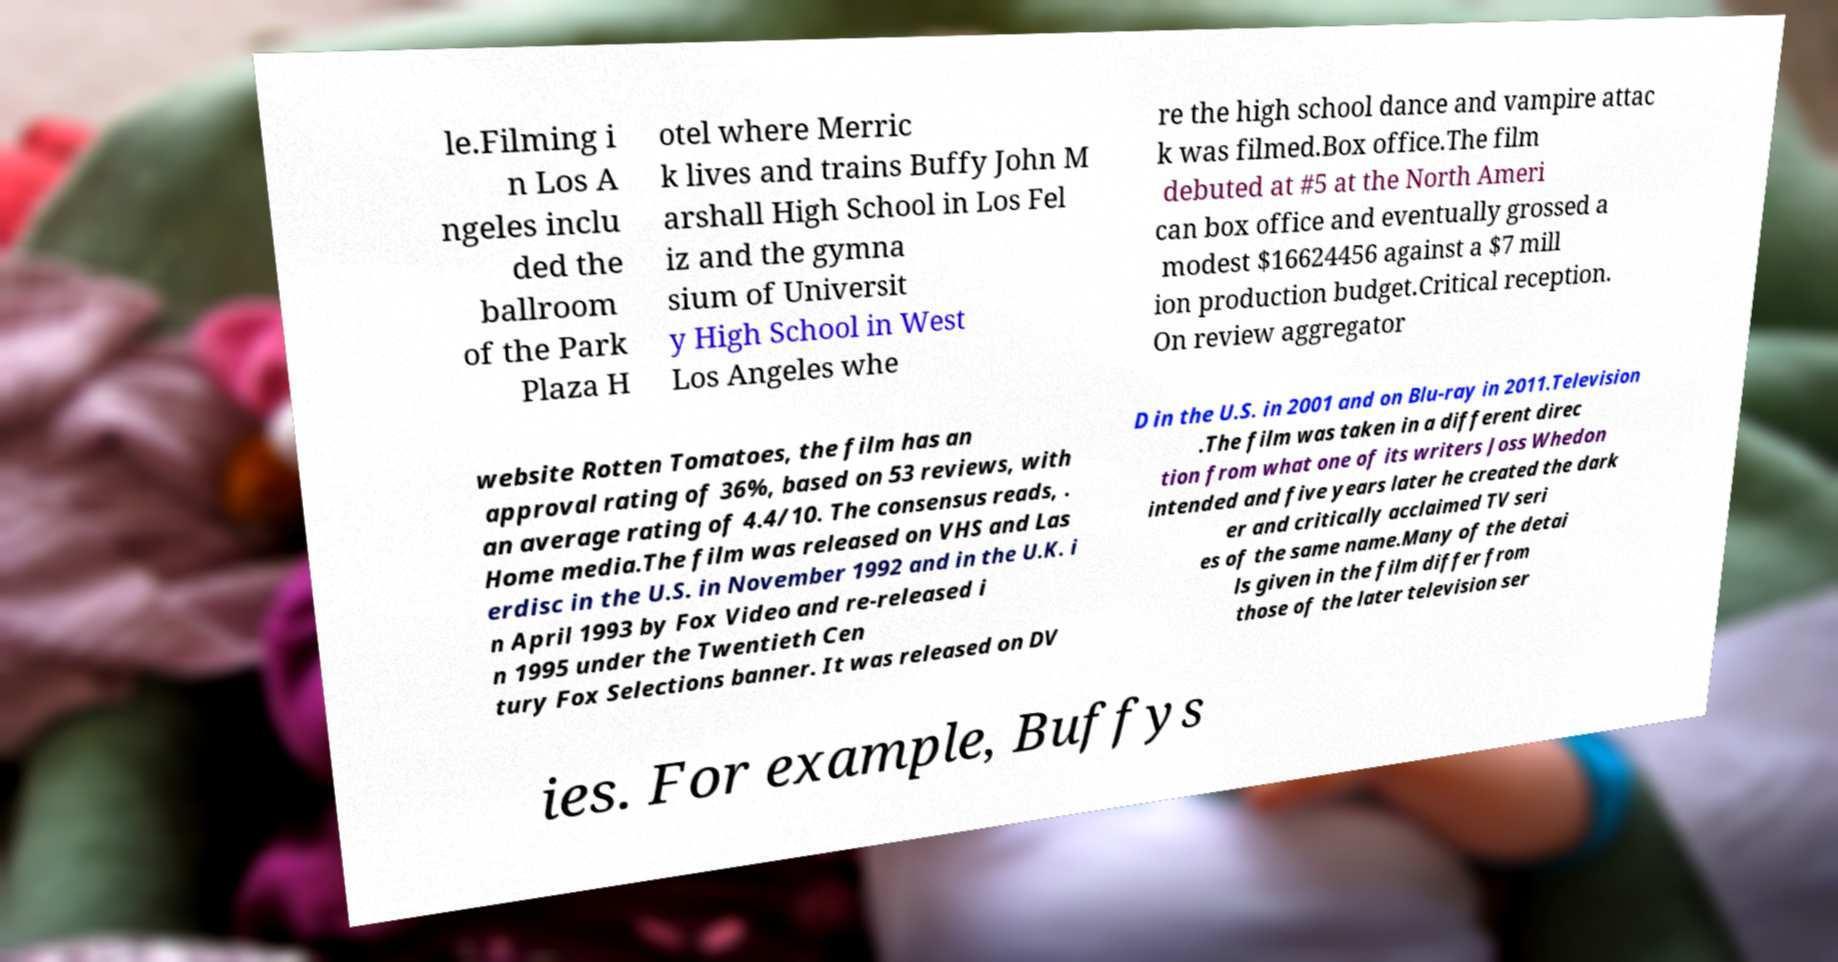Could you assist in decoding the text presented in this image and type it out clearly? le.Filming i n Los A ngeles inclu ded the ballroom of the Park Plaza H otel where Merric k lives and trains Buffy John M arshall High School in Los Fel iz and the gymna sium of Universit y High School in West Los Angeles whe re the high school dance and vampire attac k was filmed.Box office.The film debuted at #5 at the North Ameri can box office and eventually grossed a modest $16624456 against a $7 mill ion production budget.Critical reception. On review aggregator website Rotten Tomatoes, the film has an approval rating of 36%, based on 53 reviews, with an average rating of 4.4/10. The consensus reads, . Home media.The film was released on VHS and Las erdisc in the U.S. in November 1992 and in the U.K. i n April 1993 by Fox Video and re-released i n 1995 under the Twentieth Cen tury Fox Selections banner. It was released on DV D in the U.S. in 2001 and on Blu-ray in 2011.Television .The film was taken in a different direc tion from what one of its writers Joss Whedon intended and five years later he created the dark er and critically acclaimed TV seri es of the same name.Many of the detai ls given in the film differ from those of the later television ser ies. For example, Buffys 